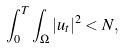<formula> <loc_0><loc_0><loc_500><loc_500>\int ^ { T } _ { 0 } \int _ { \Omega } | u _ { t } | ^ { 2 } < N ,</formula> 